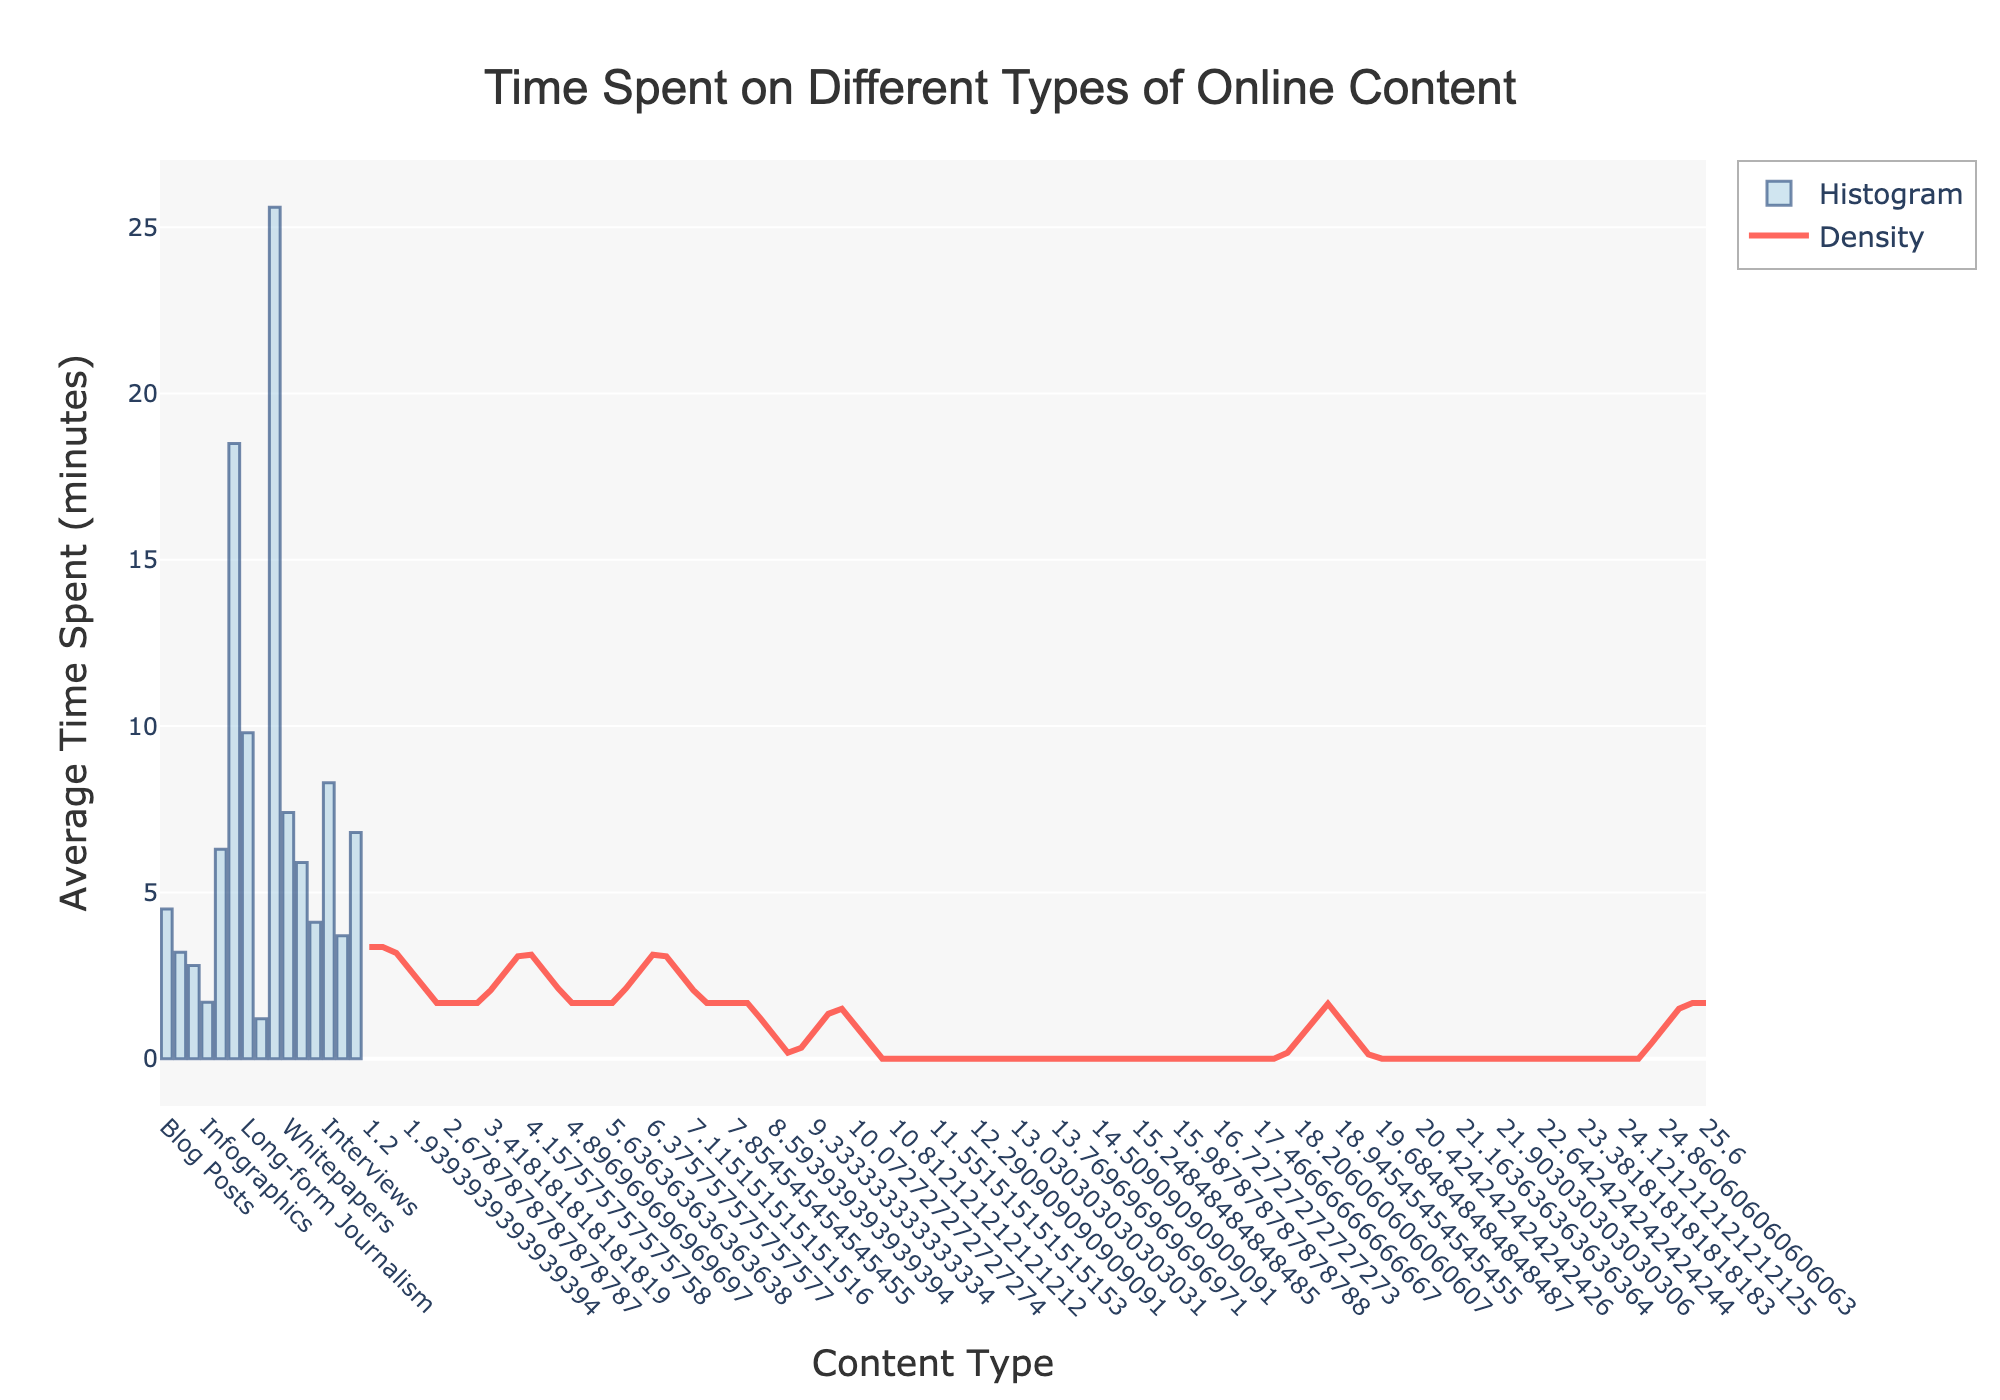What's the title of the plot? The title of the plot is typically displayed at the top, centrally aligned. In this figure, the title is "Time Spent on Different Types of Online Content".
Answer: Time Spent on Different Types of Online Content Which content type has the highest average time spent? To find the content type with the highest average time spent, look at the tallest bar in the histogram. In this case, the "E-books" bar is the tallest.
Answer: E-books What is the average time spent on Podcasts? Locate the bar labeled "Podcasts" on the x-axis. The height of the bar will give you the average time spent, which is 18.5 minutes.
Answer: 18.5 minutes Between Blog Posts and News Articles, which has a higher average time spent? Compare the heights of the bars for "Blog Posts" and "News Articles". The "Blog Posts" bar is taller than the "News Articles" bar, indicating a higher average time spent.
Answer: Blog Posts What is the average time spent on content types with less than 5 minutes on average? Identify the content types with bars shorter than the line representing 5 minutes on the y-axis. These include Social Media Posts (1.2), Infographics (1.7), Press Releases (2.8), News Articles (3.2), Opinion Pieces (3.7), and Product Reviews (4.1). Add these values and divide by the number of content types: (1.2 + 1.7 + 2.8 + 3.2 + 3.7 + 4.1)/6.
Answer: 2.78 minutes How does the KDE curve help in understanding the data? The KDE (density curve) smooths out the histogram data to show the overall distribution trend. It helps visualize where most of the values are concentrated and how those values spread out. For example, high peaks in the KDE curve show where average times are more common.
Answer: Shows the overall distribution trend Which content type has an average time spent closest to the median value? To find the median, arrange the average time spent values in ascending order and find the middle value. The median value in this data set (ordered as: 1.2, 1.7, 2.8, 3.2, 3.7, 4.1, 4.5, 5.9, 6.3, 6.8, 7.4, 8.3, 9.8, 18.5, 25.6) is 4.5, which corresponds to Blog Posts.
Answer: Blog Posts Is the KDE curve uniformly distributed? A KDE curve is uniformly distributed if it forms a horizontal line. In this plot, the KDE curve has peaks and valleys, indicating that it is not uniformly distributed.
Answer: No What does the y-axis represent in this plot? The y-axis represents the average time spent in minutes on different types of online content. Each bar's height corresponds to the average time spent on the respective content type.
Answer: Average Time Spent (minutes) Looking at the plot, which content types could be considered as outliers in terms of average time spent? Outliers are values that deviate significantly from the rest of the data. Identify extreme values far from most other bars. In this case, "Podcasts" (18.5 minutes) and "E-books" (25.6 minutes) are significantly higher than others, making them outliers.
Answer: Podcasts and E-books 